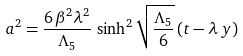Convert formula to latex. <formula><loc_0><loc_0><loc_500><loc_500>a ^ { 2 } = \frac { 6 \, \beta ^ { 2 } \lambda ^ { 2 } } { \Lambda _ { 5 } } \, \sinh ^ { 2 } { \sqrt { \frac { \Lambda _ { 5 } } { 6 } } \, ( t - \lambda \, y ) }</formula> 